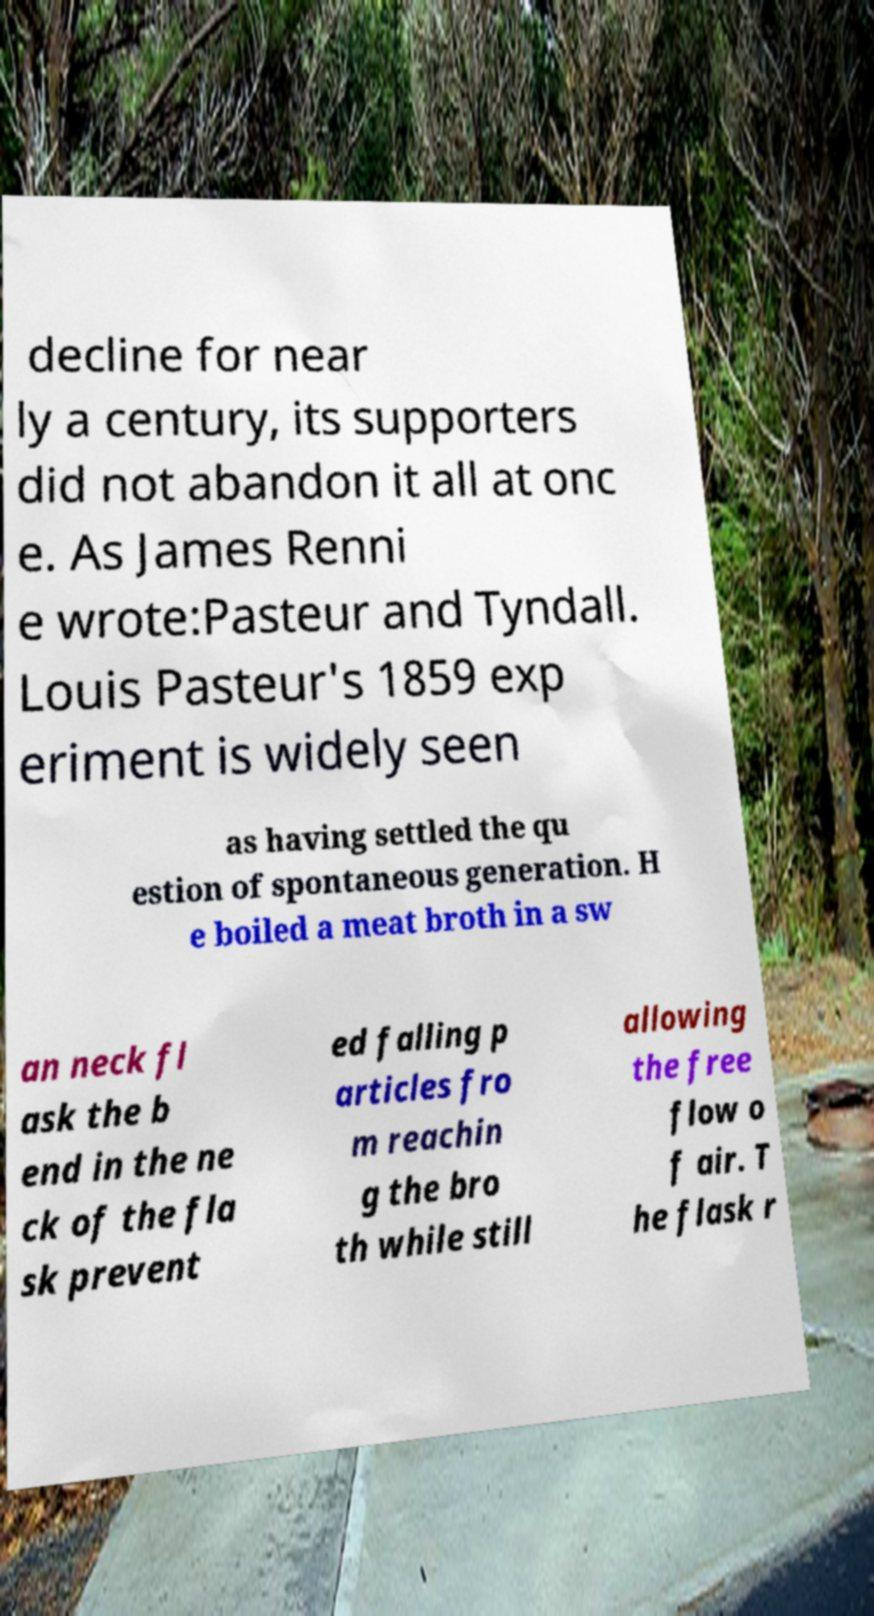For documentation purposes, I need the text within this image transcribed. Could you provide that? decline for near ly a century, its supporters did not abandon it all at onc e. As James Renni e wrote:Pasteur and Tyndall. Louis Pasteur's 1859 exp eriment is widely seen as having settled the qu estion of spontaneous generation. H e boiled a meat broth in a sw an neck fl ask the b end in the ne ck of the fla sk prevent ed falling p articles fro m reachin g the bro th while still allowing the free flow o f air. T he flask r 